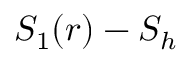<formula> <loc_0><loc_0><loc_500><loc_500>S _ { 1 } ( r ) - S _ { h }</formula> 